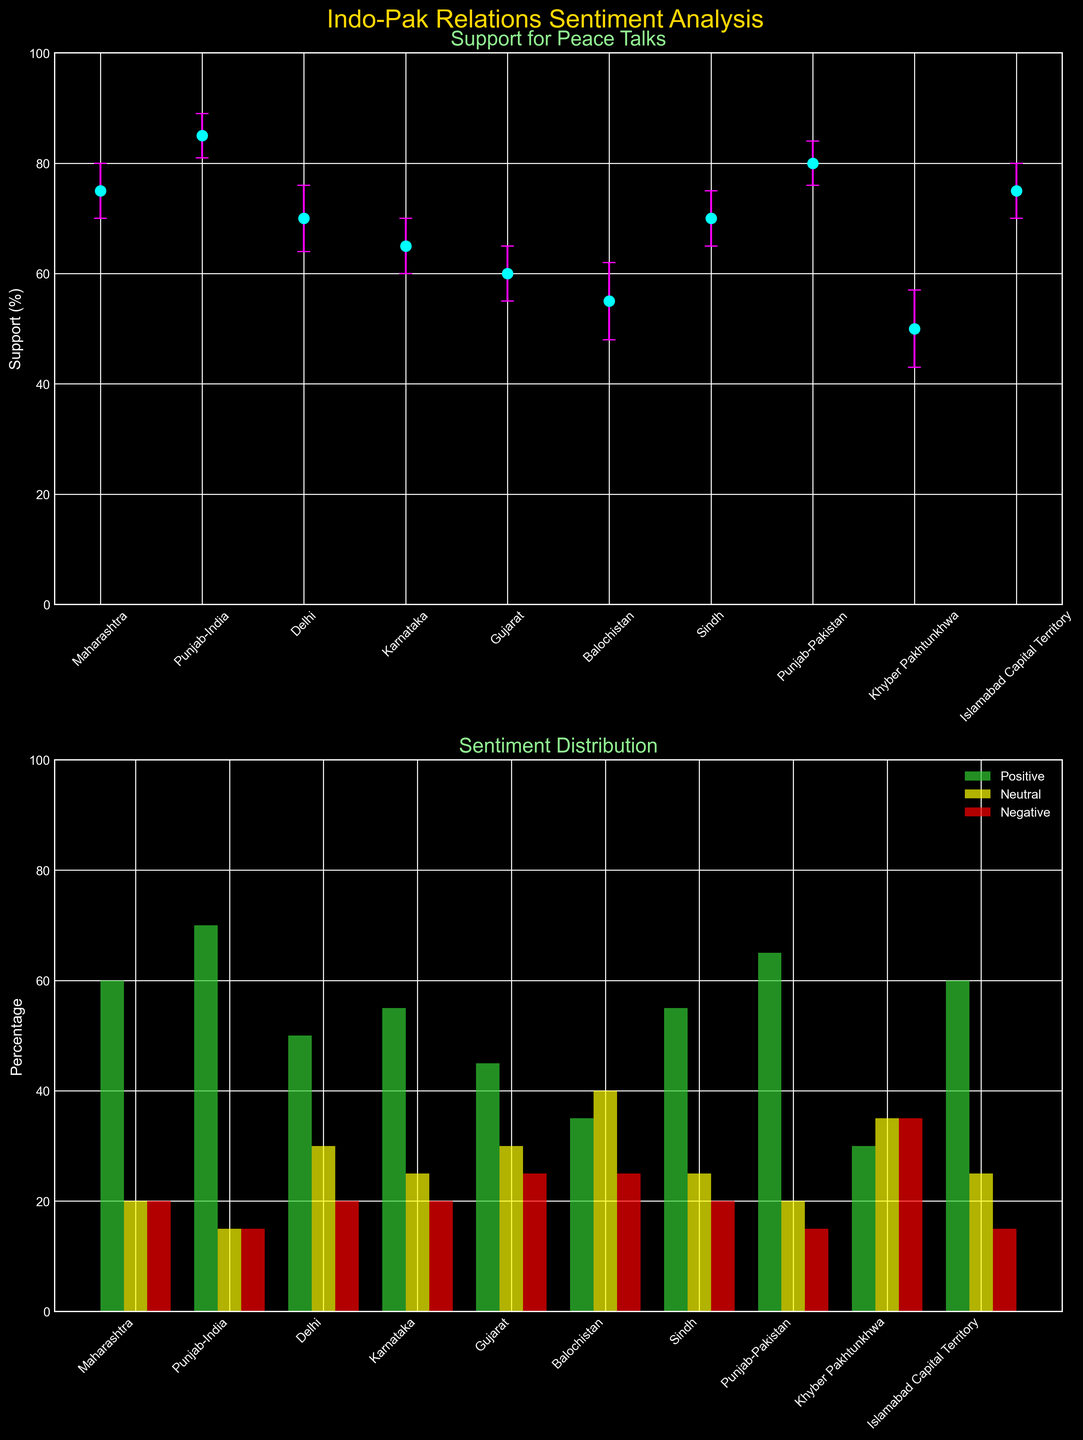What is the title of the first subplot? The title for any subplot is usually located directly above the respective plotting area. In this case, it reads "Support for Peace Talks," indicating the subplot displays information about the level of support for peace talks with error margins.
Answer: Support for Peace Talks Which state/province has the highest percentage of positive sentiment? From the second subplot depicting sentiment distribution, find the bar labeled 'Positive' with the largest value. Here, Punjab-India shows a positive sentiment percentage of 70%, which is the highest among all states/provinces.
Answer: Punjab-India How does support for peace talks in Maharashtra compare to that in Gujarat? Refer to the first subplot under "Support for Peace Talks". Check the data points and their error bars for both Maharashtra and Gujarat. Maharashtra shows 75%, whereas Gujarat shows 60%, indicating higher support in Maharashtra.
Answer: Maharashtra has higher support If we want to find provinces with neutral sentiments above 25%, how many such provinces are there? In the second subplot, examine the neutral sentiment bars. Count how many of these bars exceed the 25% mark. Balochistan, Khyber Pakhtunkhwa, and Gujarat have neutral sentiment percentages above 25%.
Answer: 3 provinces What is the error margin for positive sentiment in Sindh? The error information is provided in the form of error bars in both subplots. Specifically for Sindh in the second subplot, you would refer to the bar indicating positive sentiment and check its corresponding error margin. From the dataset, the error margin is 5%.
Answer: 5% Which state has the lowest percentage of support for peace talks? Refer to the first subplot and identify the smallest data point within the given error margins. Khyber Pakhtunkhwa exhibits the lowest support percentage for peace talks at 50%.
Answer: Khyber Pakhtunkhwa Compare the neutral sentiment percentages in Delhi and Islamabad Capital Territory. Which one is higher and by how much? Look at the neutral sentiment bars in the second subplot. Delhi's neutral sentiment is 30%, while Islamabad's neutral sentiment is 25%. The difference is calculated as 30% - 25% = 5%.
Answer: Delhi, by 5% Find the province with the highest negative sentiment percentage and state the percentage. In the second subplot, locate the tallest bar among those labeled for negative sentiment. Khyber Pakhtunkhwa shows the highest negative sentiment at 35%.
Answer: Khyber Pakhtunkhwa, 35% When considering only Indian states, which has the highest support for peace talks? Focus solely on the Indian states in the first subplot. Among them, Punjab-India has the highest support for peace talks at 85%.
Answer: Punjab-India 